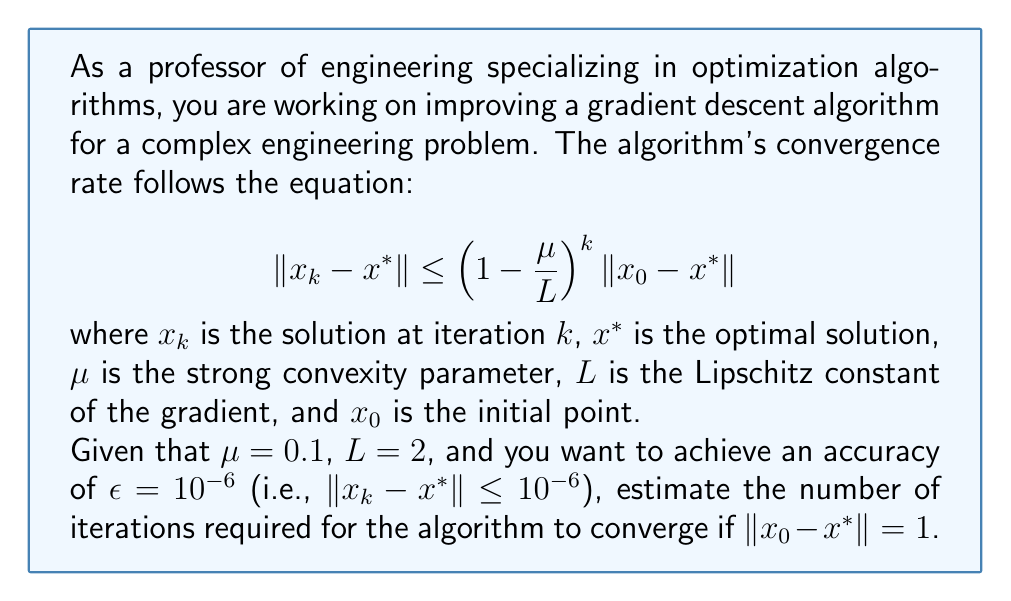Give your solution to this math problem. To solve this problem, we need to follow these steps:

1) First, let's simplify the convergence rate equation:
   $$\|x_k - x^*\| \leq \left(1 - \frac{\mu}{L}\right)^k \|x_0 - x^*\|$$

2) We want to find $k$ such that:
   $$\left(1 - \frac{\mu}{L}\right)^k \|x_0 - x^*\| \leq \epsilon$$

3) Substituting the given values:
   $$\left(1 - \frac{0.1}{2}\right)^k \cdot 1 \leq 10^{-6}$$

4) Simplify:
   $$0.95^k \leq 10^{-6}$$

5) Take the natural logarithm of both sides:
   $$k \ln(0.95) \leq \ln(10^{-6})$$

6) Solve for $k$:
   $$k \geq \frac{\ln(10^{-6})}{\ln(0.95)} \approx 270.26$$

7) Since $k$ must be an integer, we round up to the nearest whole number.
Answer: The estimated number of iterations required for the algorithm to converge is 271. 